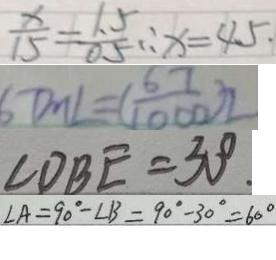<formula> <loc_0><loc_0><loc_500><loc_500>\frac { x } { 1 5 } = \frac { 1 . 5 } { 0 . 5 } \therefore x = 4 5 \cdot 
 6 7 m L = ( \frac { 6 7 } { 1 0 0 0 } ) 2 
 \angle D B E = 3 0 ^ { \circ } . 
 \angle A = 9 0 ^ { \circ } - \angle B = 9 0 ^ { \circ } - 3 0 ^ { \circ } = 6 0 ^ { \circ }</formula> 